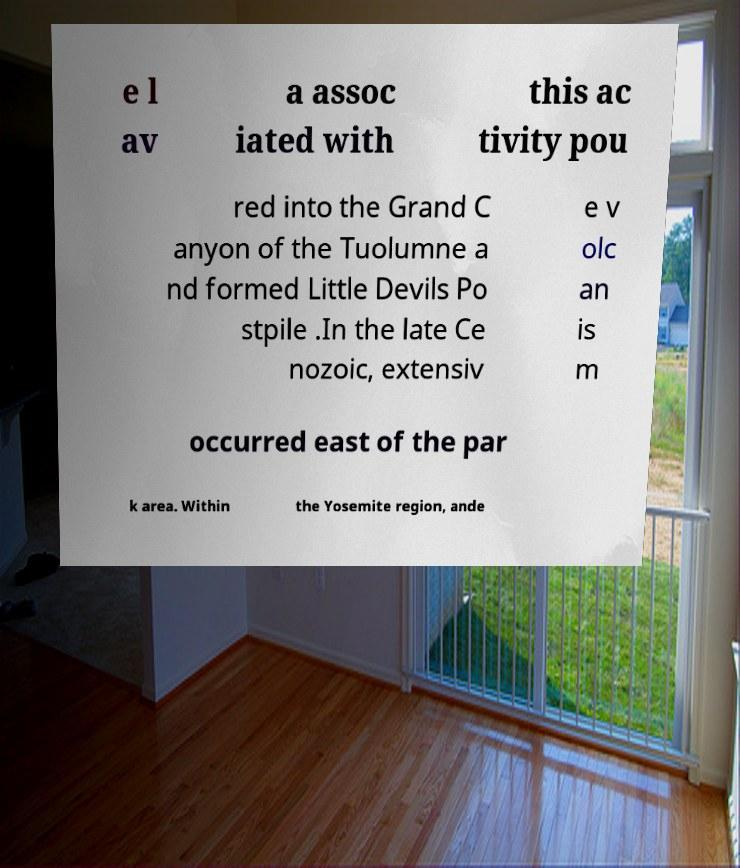Could you assist in decoding the text presented in this image and type it out clearly? e l av a assoc iated with this ac tivity pou red into the Grand C anyon of the Tuolumne a nd formed Little Devils Po stpile .In the late Ce nozoic, extensiv e v olc an is m occurred east of the par k area. Within the Yosemite region, ande 